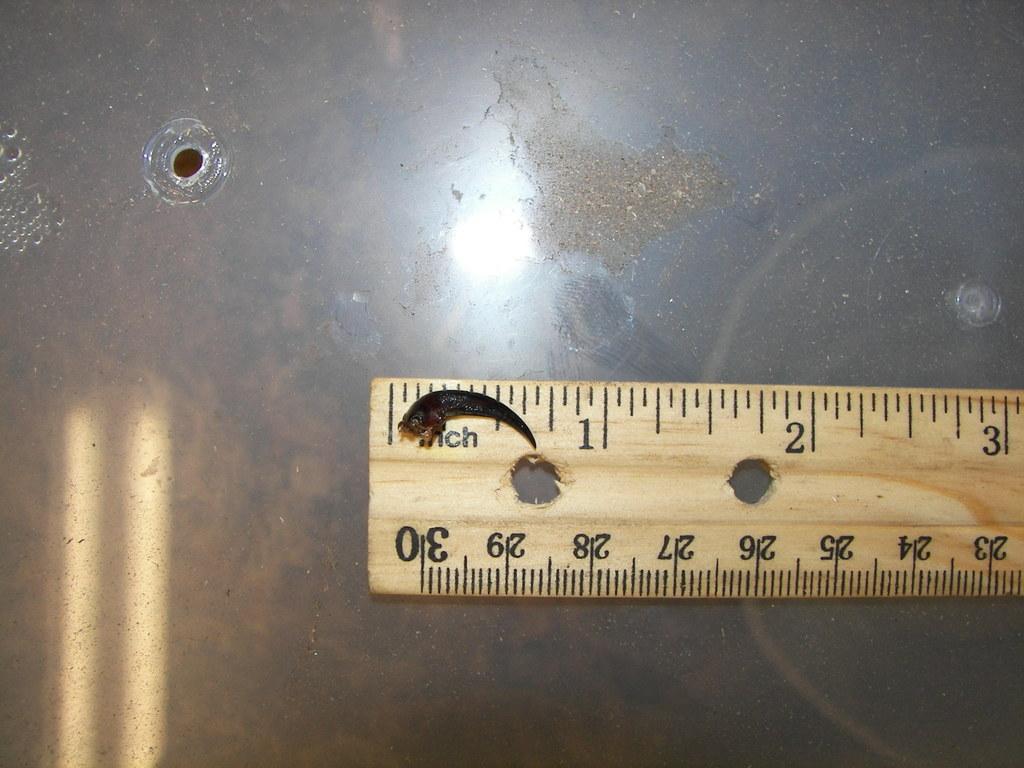What unit of measurement is this ruler measuring?
Your response must be concise. Inch. What is the largest measurement on the bottom of the ruler?
Your response must be concise. 30. 